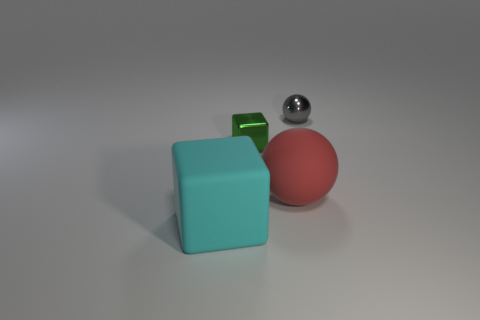What can you tell me about the lighting in this scene? The lighting in the image appears to be soft and diffused, coming from above, which creates gentle shadows and highlights the textures of the objects. 